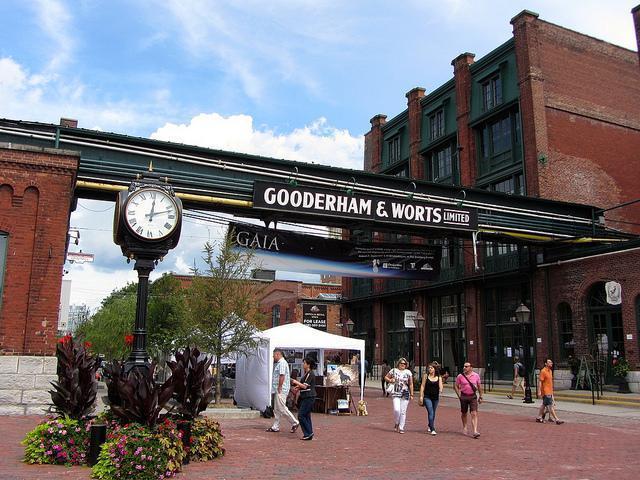How many females are in this picture?
Give a very brief answer. 3. 